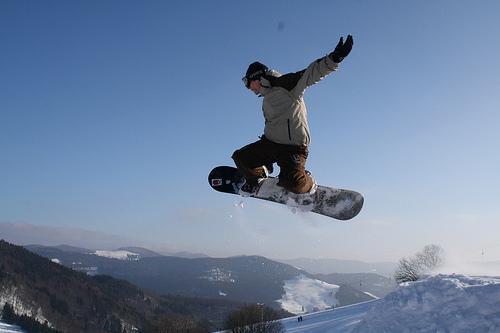How many skiers in the photo?
Give a very brief answer. 1. 